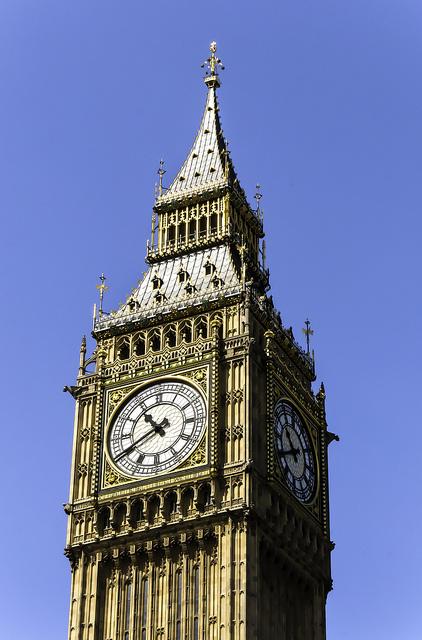What time is on the clock?
Write a very short answer. 10:40. Is this the Big Ben clock tower?
Give a very brief answer. Yes. Is it day time?
Write a very short answer. Yes. How many windows are showing?
Write a very short answer. 0. What time is shown in the picture?
Short answer required. 10:40. What time does the clock say?
Concise answer only. 10:40. Is it a sunny day?
Write a very short answer. Yes. What time is it?
Short answer required. 10:40. 